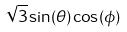Convert formula to latex. <formula><loc_0><loc_0><loc_500><loc_500>\sqrt { 3 } \sin ( \theta ) \cos ( \phi )</formula> 